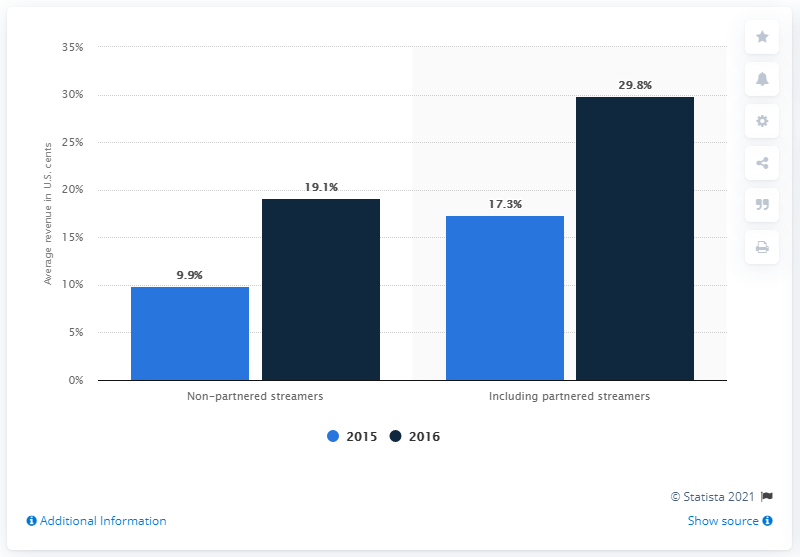Highlight a few significant elements in this photo. The average of including partnered streamers is 23.55. In 2016, the revenue generated by non-partnered streamers was 19.1 million U.S. dollars. 